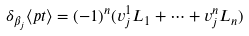Convert formula to latex. <formula><loc_0><loc_0><loc_500><loc_500>\delta _ { \beta _ { j } } \langle p t \rangle = ( - 1 ) ^ { n } ( v _ { j } ^ { 1 } L _ { 1 } + \cdots + v _ { j } ^ { n } L _ { n } )</formula> 